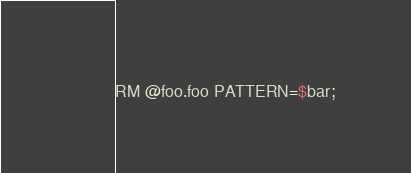<code> <loc_0><loc_0><loc_500><loc_500><_SQL_>RM @foo.foo PATTERN=$bar;
</code> 